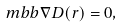<formula> <loc_0><loc_0><loc_500><loc_500>\ m b b { \nabla } { D } ( { r } ) = 0 ,</formula> 